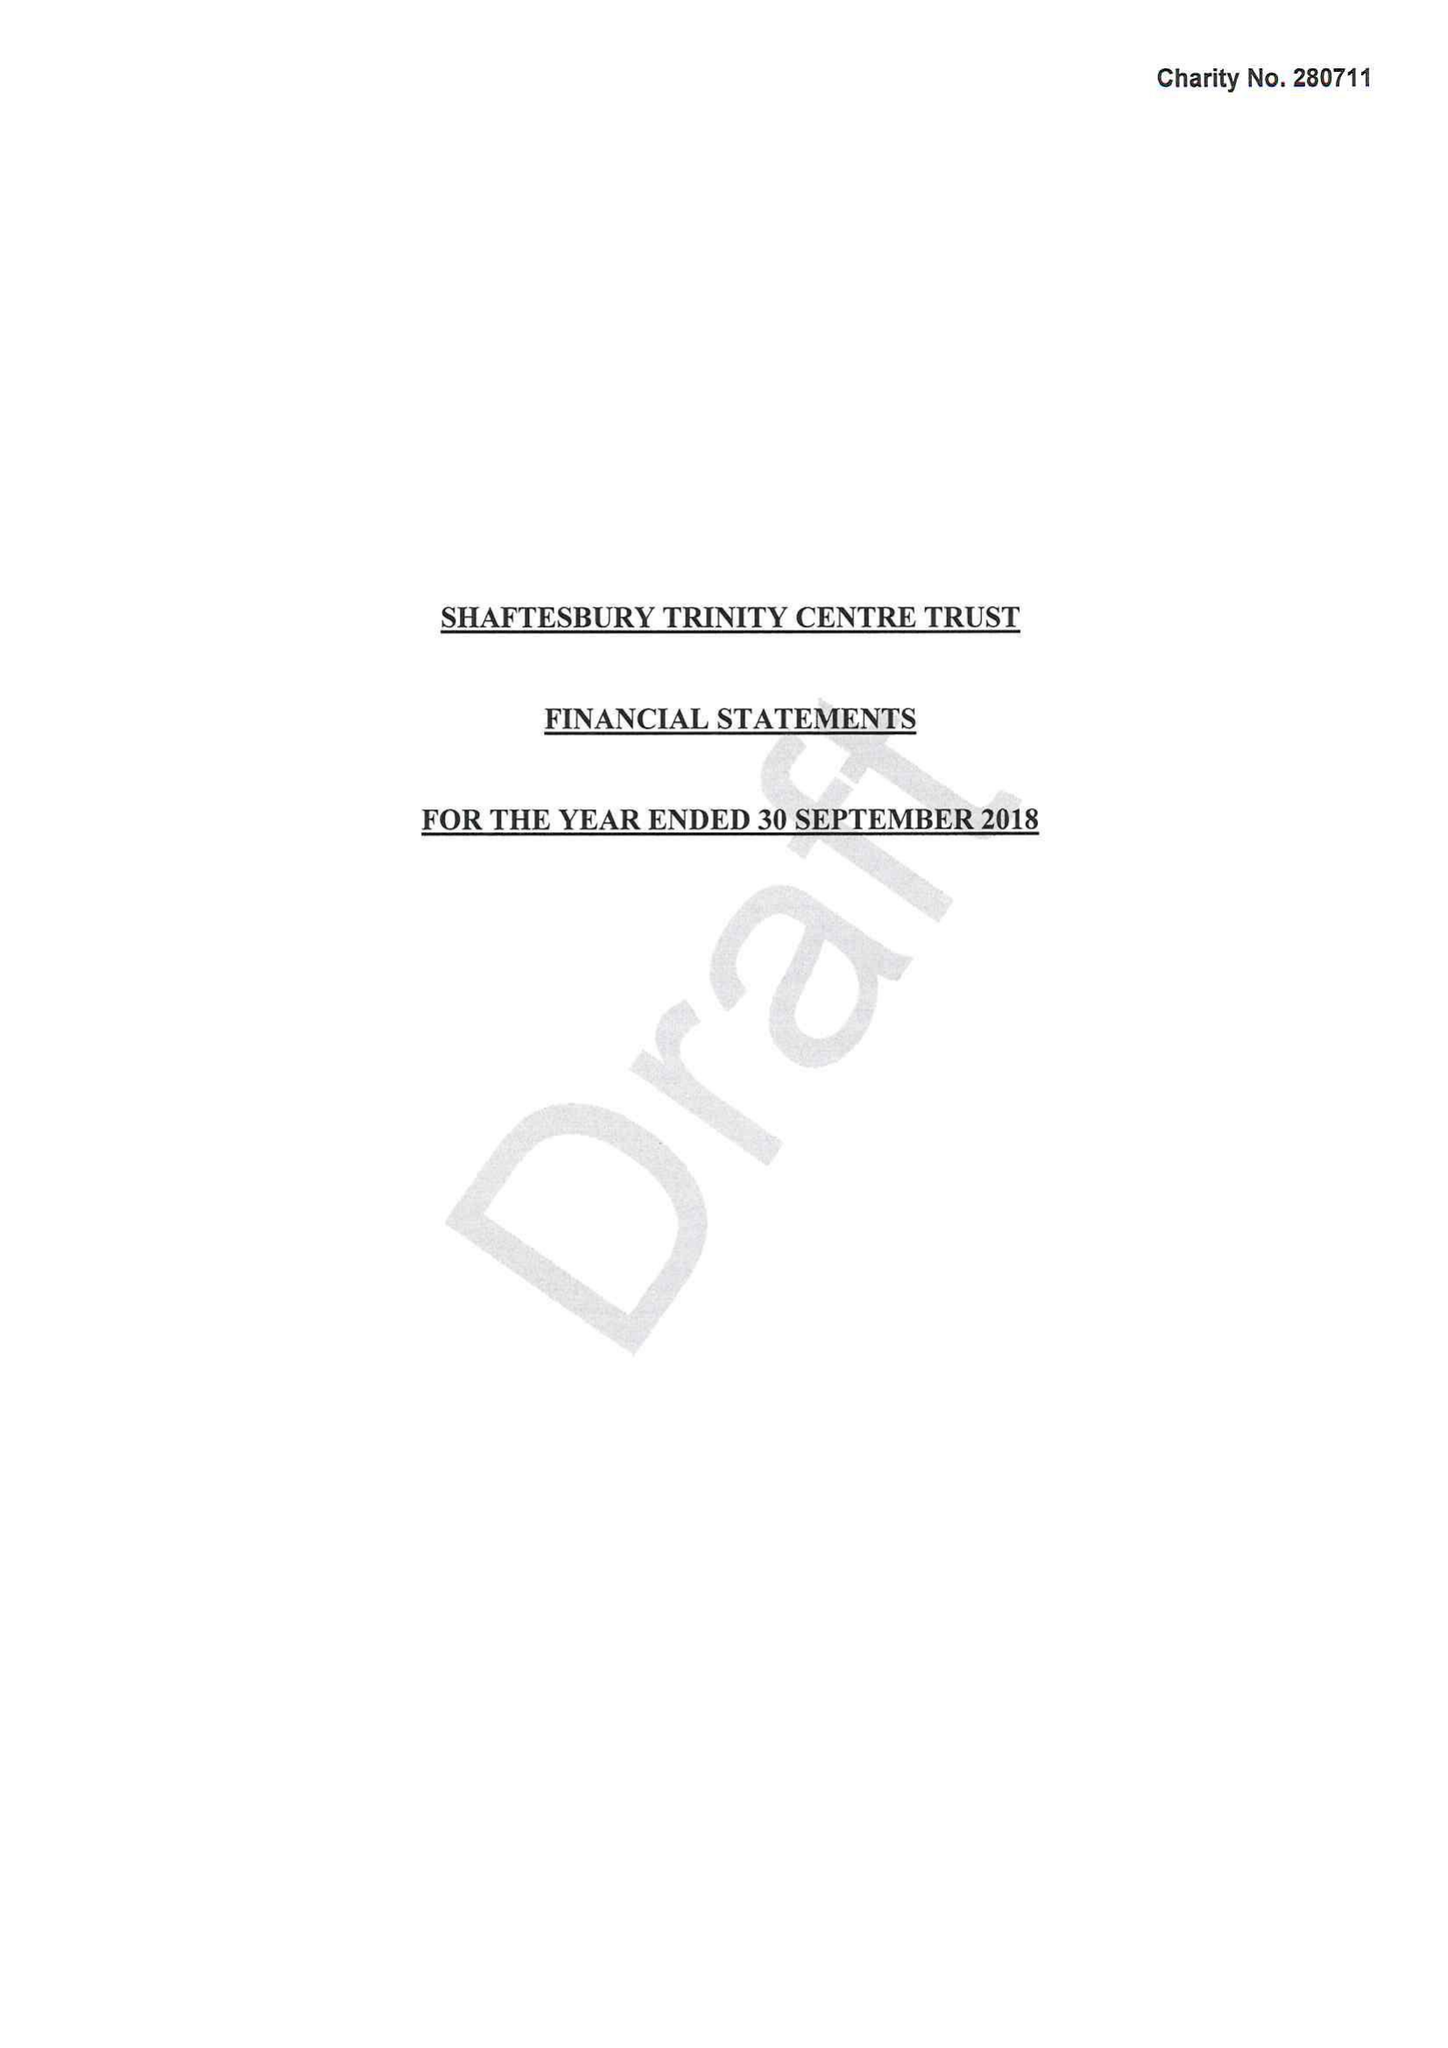What is the value for the charity_number?
Answer the question using a single word or phrase. 280711 